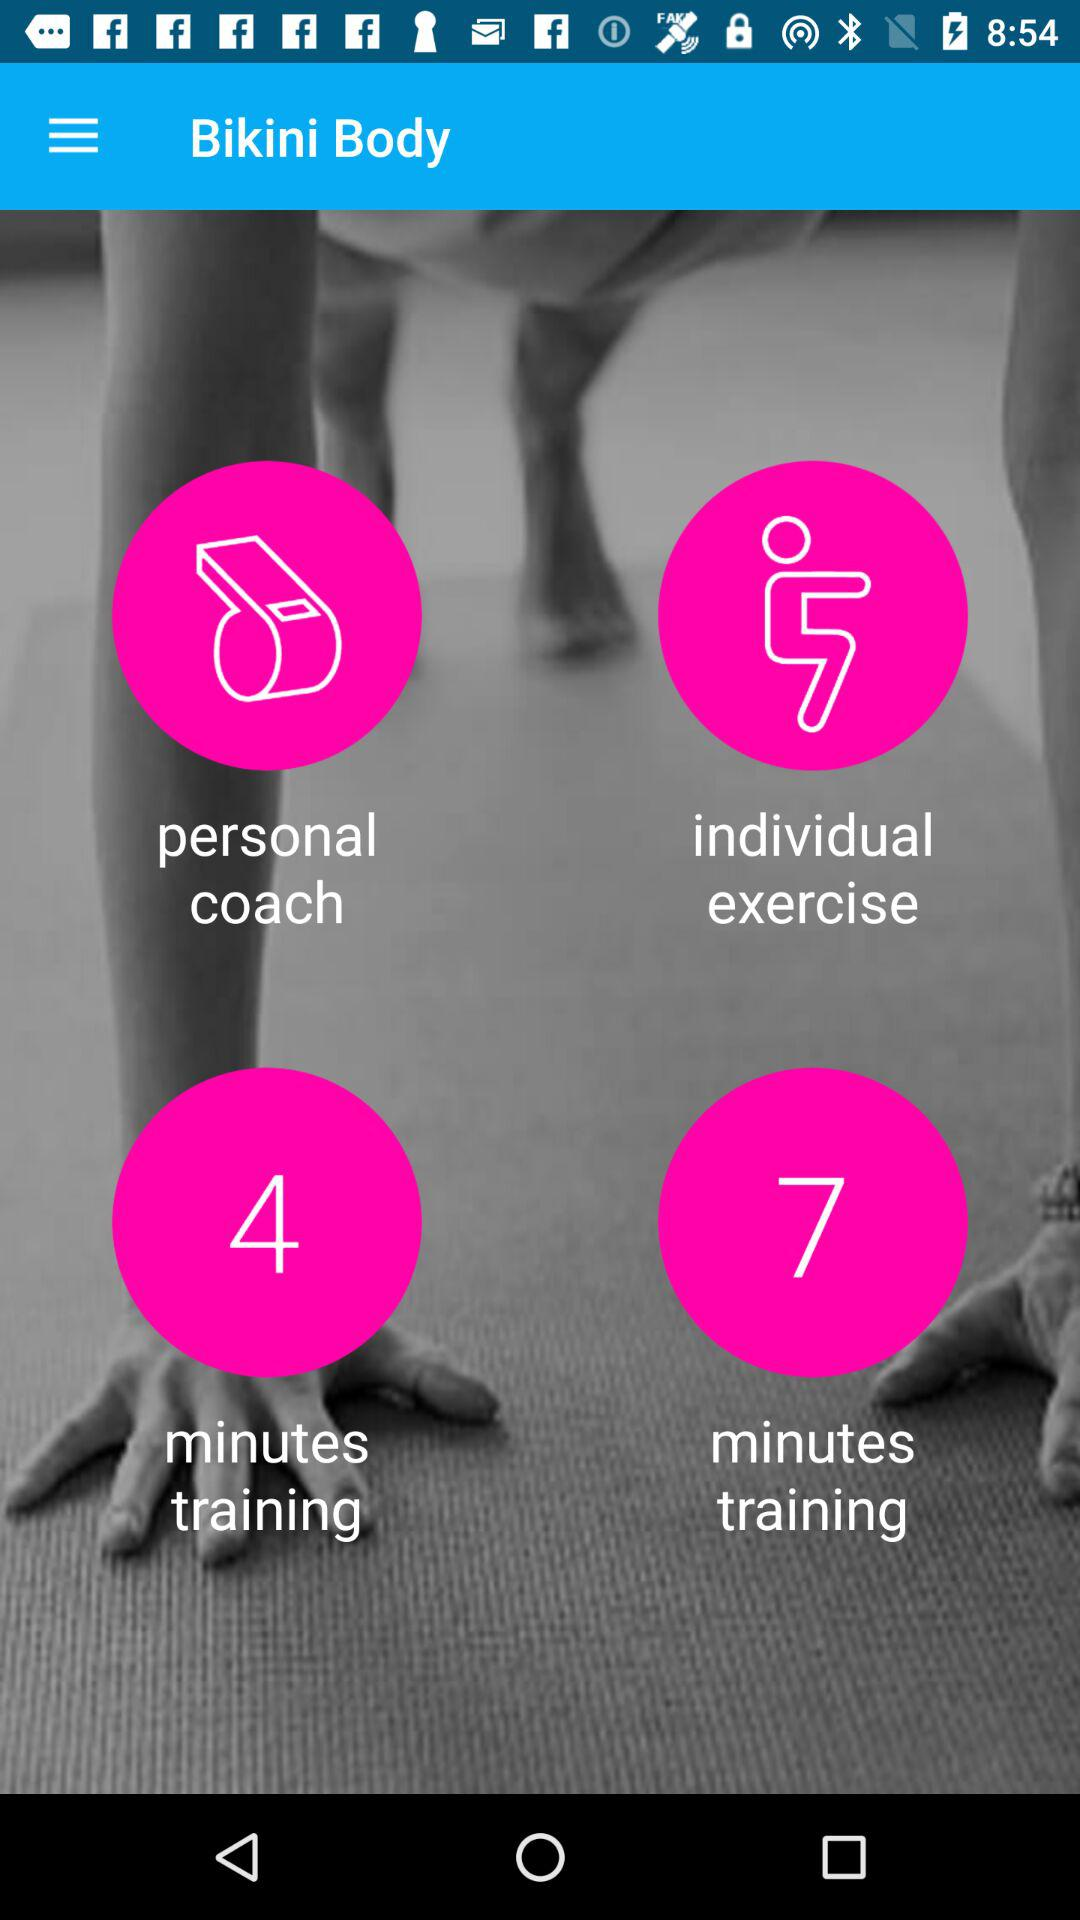How many minutes are there for training?
When the provided information is insufficient, respond with <no answer>. <no answer> 